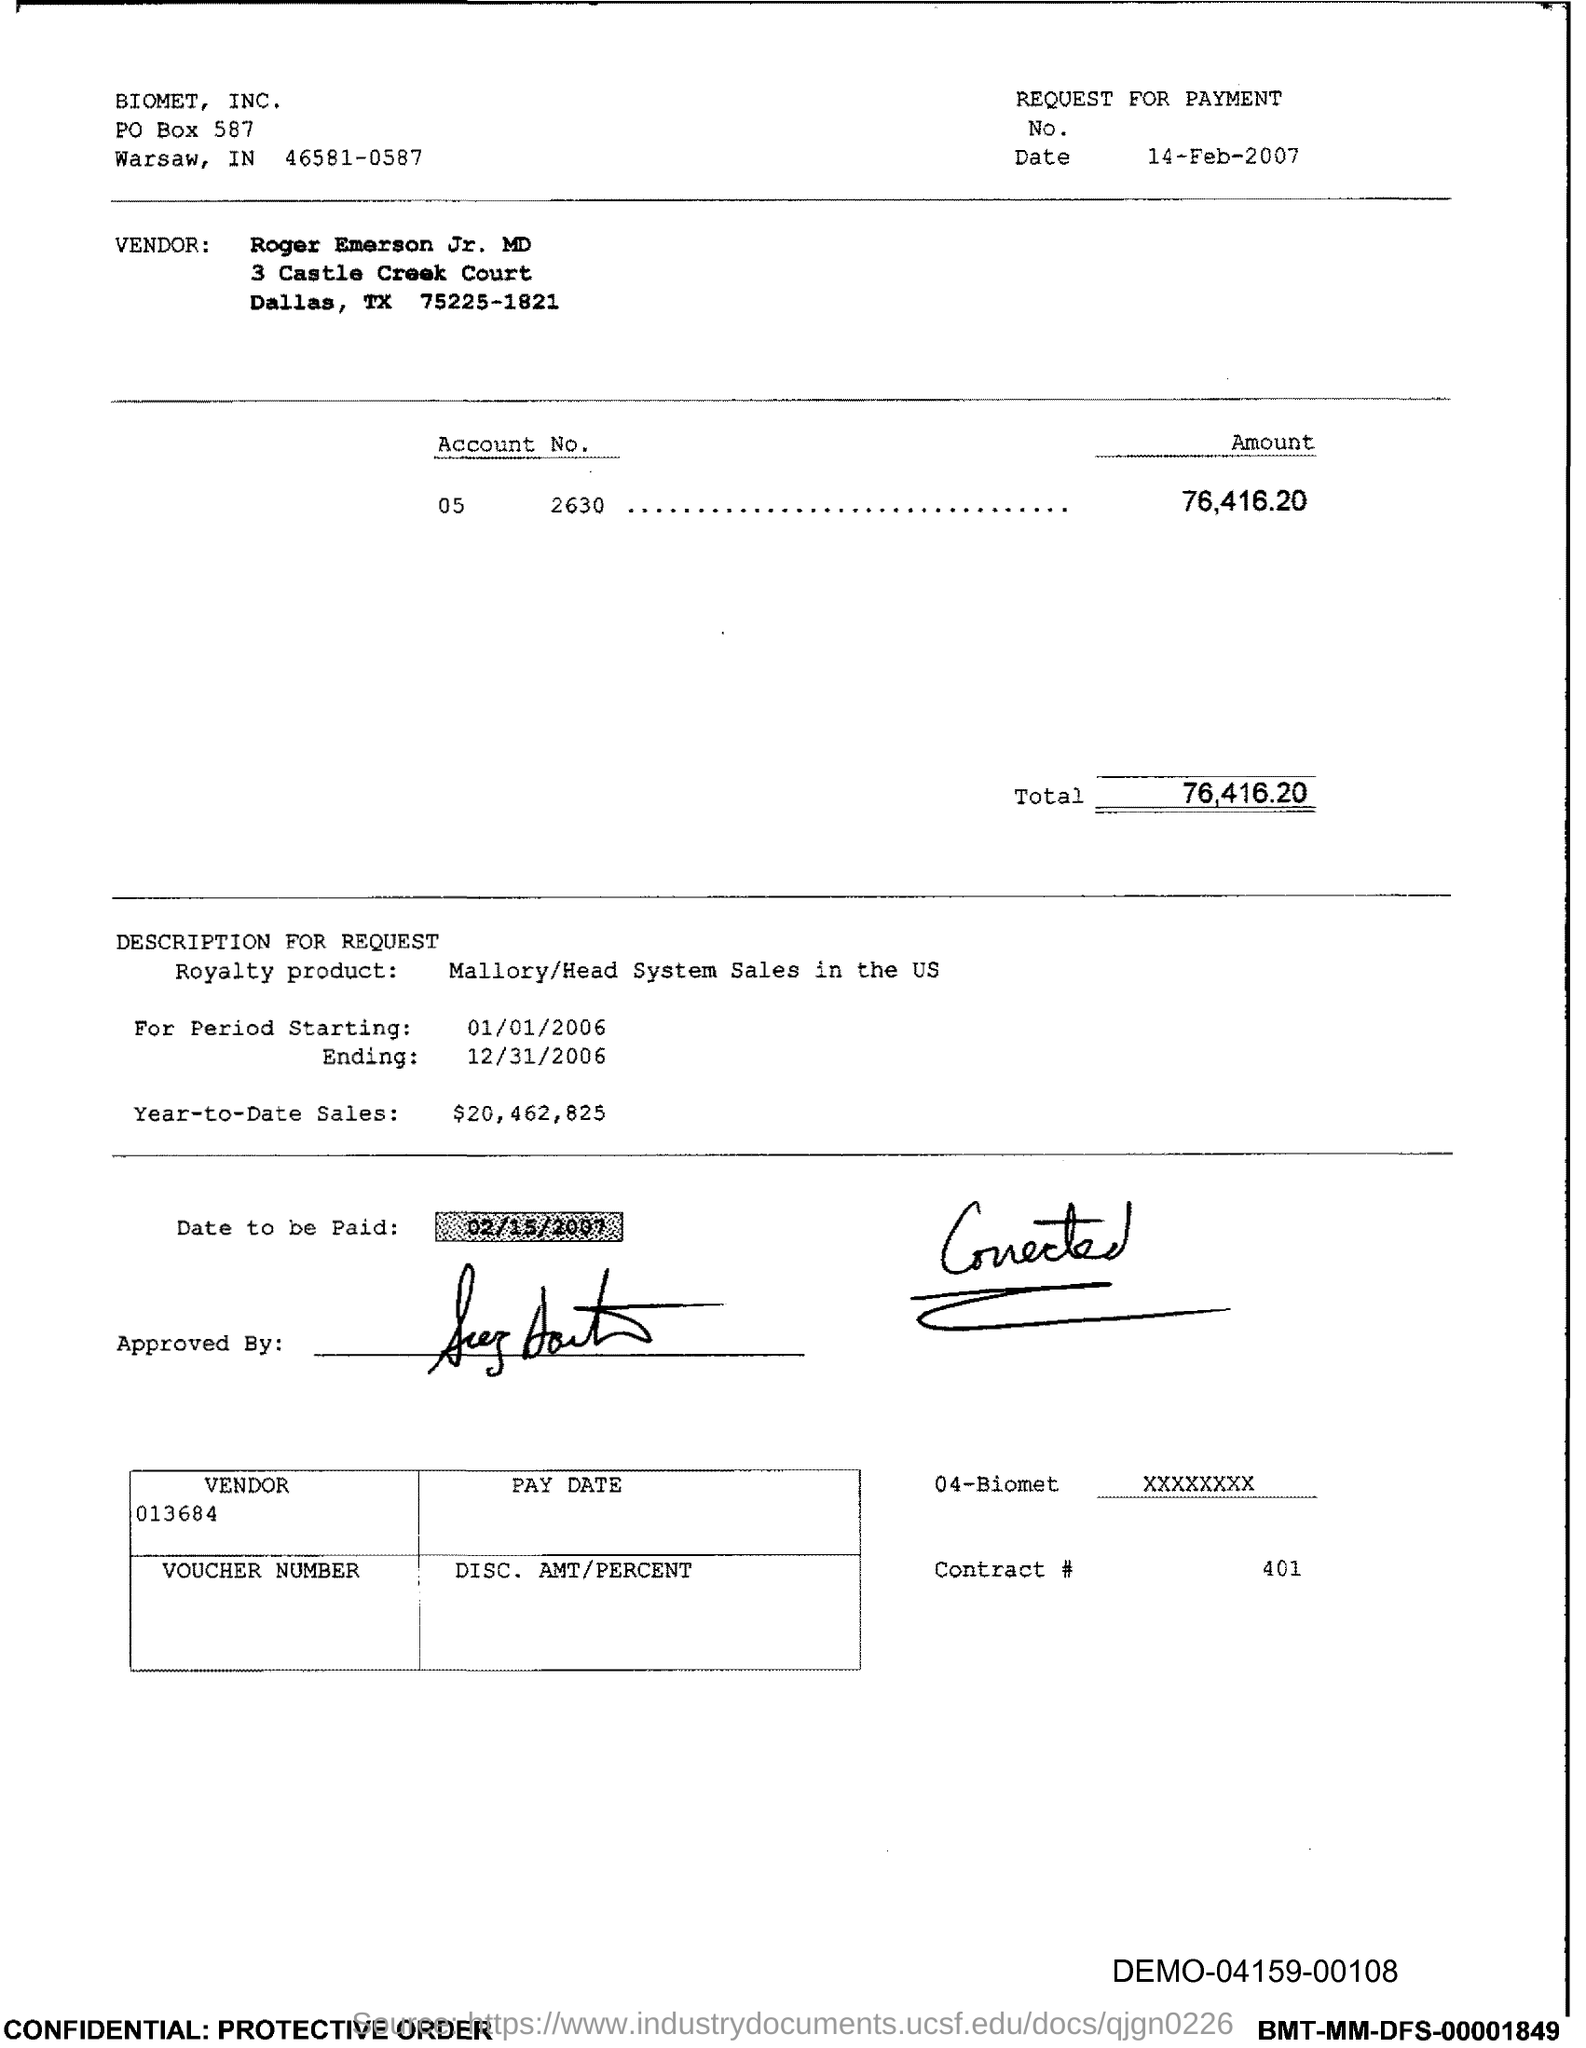What is the date mentioned under "REQUEST FOR PAYMENT"?
Provide a short and direct response. 14-Feb-2007. What is the "PO BOX" number of "BIOMET, INC."?
Ensure brevity in your answer.  587. What is the "Account No." mentioned here?
Offer a very short reply. 05  2630. What is the total "Amount" that has to be paid?
Your response must be concise. 76,416.20. When is the "period starting"?
Give a very brief answer. 01/01/2006. When is the period "Ending"?
Provide a short and direct response. 12/31/2006. What is the "Date to be paid" mentioned under "DESCRIPTION FOR REQUEST"?
Give a very brief answer. 02/15/2007. What is the DEMO number given at the right bottom of the page?
Offer a terse response. DEMO-04159-00108. 